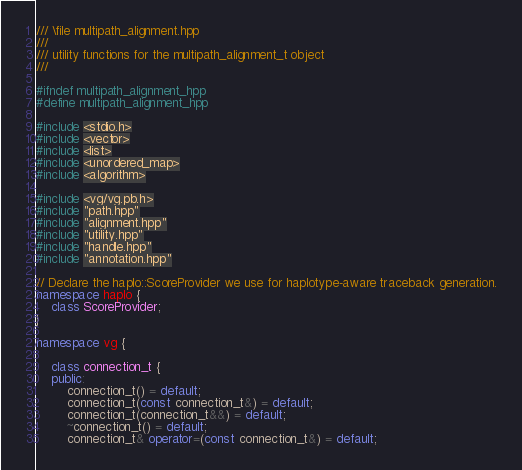<code> <loc_0><loc_0><loc_500><loc_500><_C++_>/// \file multipath_alignment.hpp
///
/// utility functions for the multipath_alignment_t object
///

#ifndef multipath_alignment_hpp
#define multipath_alignment_hpp

#include <stdio.h>
#include <vector>
#include <list>
#include <unordered_map>
#include <algorithm>

#include <vg/vg.pb.h>
#include "path.hpp"
#include "alignment.hpp"
#include "utility.hpp"
#include "handle.hpp"
#include "annotation.hpp"

// Declare the haplo::ScoreProvider we use for haplotype-aware traceback generation.
namespace haplo {
    class ScoreProvider;
}

namespace vg {

    class connection_t {
    public:
        connection_t() = default;
        connection_t(const connection_t&) = default;
        connection_t(connection_t&&) = default;
        ~connection_t() = default;
        connection_t& operator=(const connection_t&) = default;</code> 